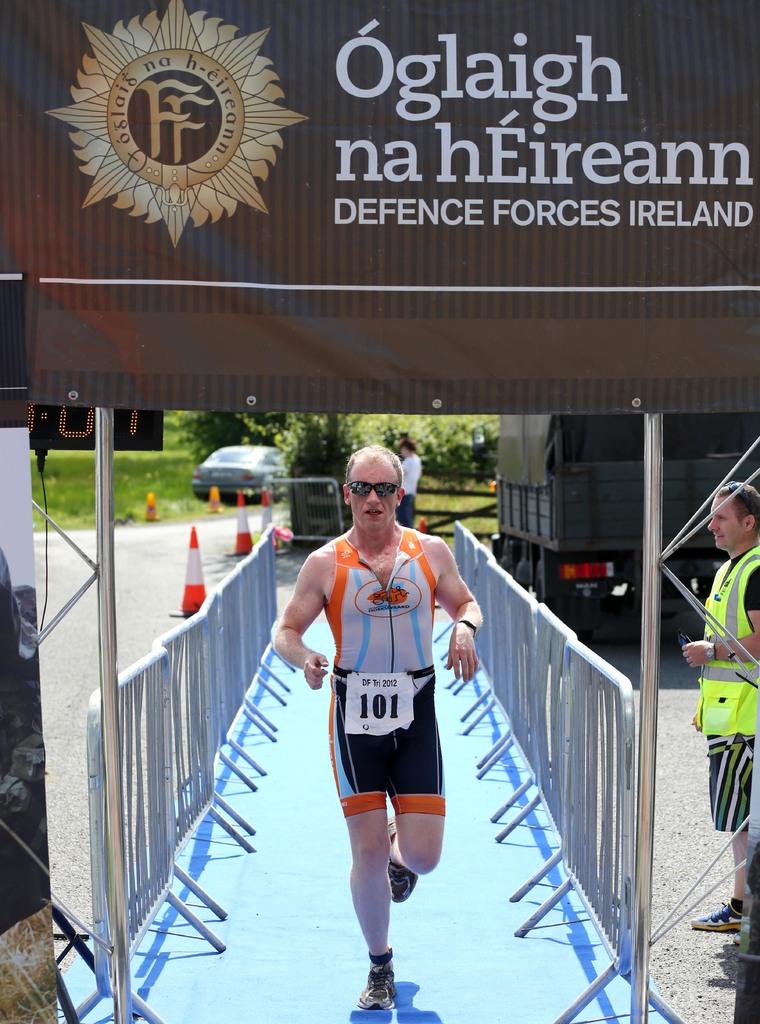What country sponsors this race?
Your answer should be very brief. Ireland. What is the number on that man's tag?
Keep it short and to the point. 101. 